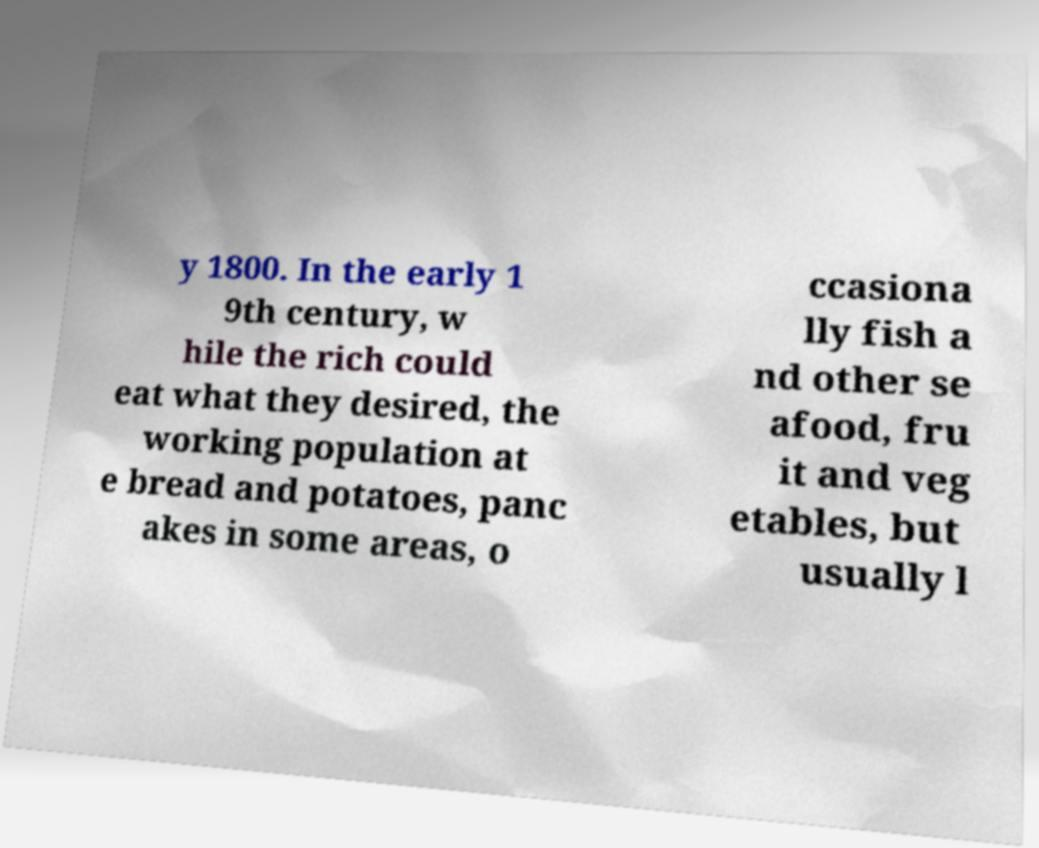Could you extract and type out the text from this image? y 1800. In the early 1 9th century, w hile the rich could eat what they desired, the working population at e bread and potatoes, panc akes in some areas, o ccasiona lly fish a nd other se afood, fru it and veg etables, but usually l 